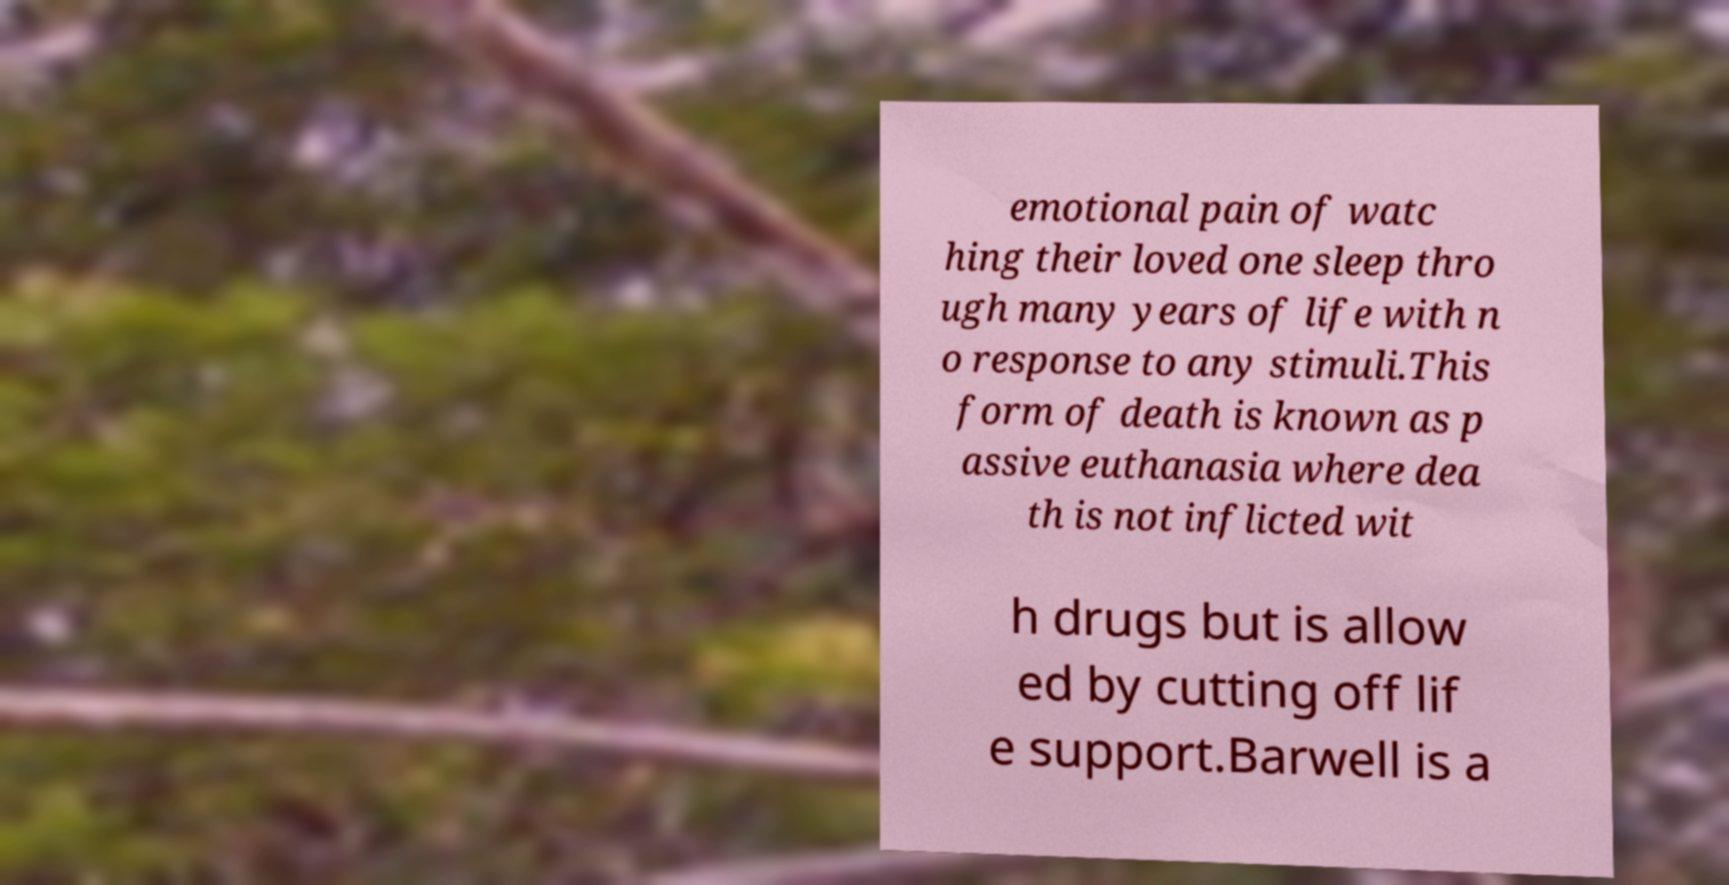Can you read and provide the text displayed in the image?This photo seems to have some interesting text. Can you extract and type it out for me? emotional pain of watc hing their loved one sleep thro ugh many years of life with n o response to any stimuli.This form of death is known as p assive euthanasia where dea th is not inflicted wit h drugs but is allow ed by cutting off lif e support.Barwell is a 